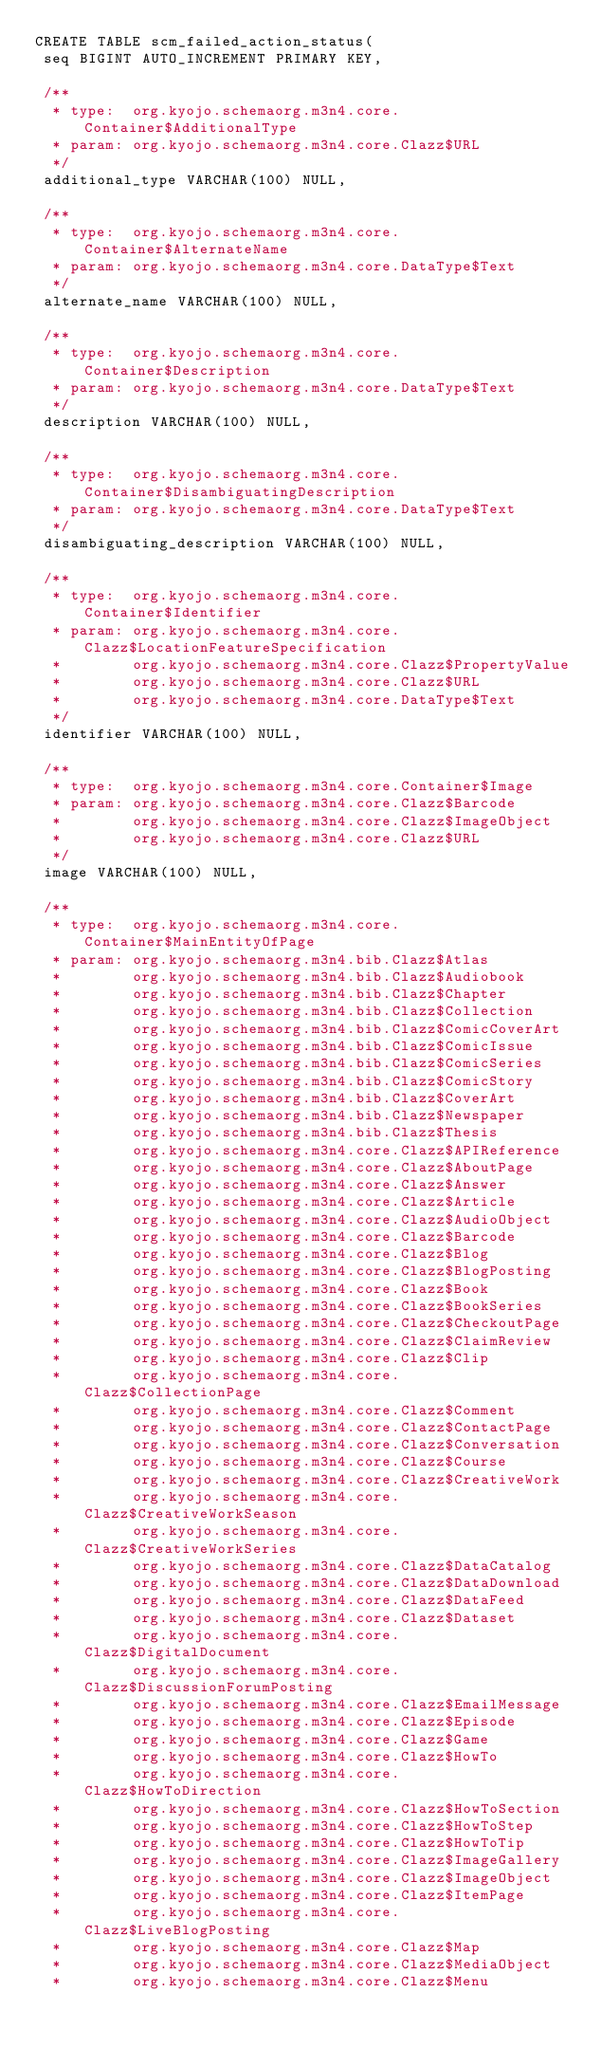<code> <loc_0><loc_0><loc_500><loc_500><_SQL_>CREATE TABLE scm_failed_action_status(
 seq BIGINT AUTO_INCREMENT PRIMARY KEY,

 /**
  * type:  org.kyojo.schemaorg.m3n4.core.Container$AdditionalType
  * param: org.kyojo.schemaorg.m3n4.core.Clazz$URL
  */
 additional_type VARCHAR(100) NULL,

 /**
  * type:  org.kyojo.schemaorg.m3n4.core.Container$AlternateName
  * param: org.kyojo.schemaorg.m3n4.core.DataType$Text
  */
 alternate_name VARCHAR(100) NULL,

 /**
  * type:  org.kyojo.schemaorg.m3n4.core.Container$Description
  * param: org.kyojo.schemaorg.m3n4.core.DataType$Text
  */
 description VARCHAR(100) NULL,

 /**
  * type:  org.kyojo.schemaorg.m3n4.core.Container$DisambiguatingDescription
  * param: org.kyojo.schemaorg.m3n4.core.DataType$Text
  */
 disambiguating_description VARCHAR(100) NULL,

 /**
  * type:  org.kyojo.schemaorg.m3n4.core.Container$Identifier
  * param: org.kyojo.schemaorg.m3n4.core.Clazz$LocationFeatureSpecification
  *        org.kyojo.schemaorg.m3n4.core.Clazz$PropertyValue
  *        org.kyojo.schemaorg.m3n4.core.Clazz$URL
  *        org.kyojo.schemaorg.m3n4.core.DataType$Text
  */
 identifier VARCHAR(100) NULL,

 /**
  * type:  org.kyojo.schemaorg.m3n4.core.Container$Image
  * param: org.kyojo.schemaorg.m3n4.core.Clazz$Barcode
  *        org.kyojo.schemaorg.m3n4.core.Clazz$ImageObject
  *        org.kyojo.schemaorg.m3n4.core.Clazz$URL
  */
 image VARCHAR(100) NULL,

 /**
  * type:  org.kyojo.schemaorg.m3n4.core.Container$MainEntityOfPage
  * param: org.kyojo.schemaorg.m3n4.bib.Clazz$Atlas
  *        org.kyojo.schemaorg.m3n4.bib.Clazz$Audiobook
  *        org.kyojo.schemaorg.m3n4.bib.Clazz$Chapter
  *        org.kyojo.schemaorg.m3n4.bib.Clazz$Collection
  *        org.kyojo.schemaorg.m3n4.bib.Clazz$ComicCoverArt
  *        org.kyojo.schemaorg.m3n4.bib.Clazz$ComicIssue
  *        org.kyojo.schemaorg.m3n4.bib.Clazz$ComicSeries
  *        org.kyojo.schemaorg.m3n4.bib.Clazz$ComicStory
  *        org.kyojo.schemaorg.m3n4.bib.Clazz$CoverArt
  *        org.kyojo.schemaorg.m3n4.bib.Clazz$Newspaper
  *        org.kyojo.schemaorg.m3n4.bib.Clazz$Thesis
  *        org.kyojo.schemaorg.m3n4.core.Clazz$APIReference
  *        org.kyojo.schemaorg.m3n4.core.Clazz$AboutPage
  *        org.kyojo.schemaorg.m3n4.core.Clazz$Answer
  *        org.kyojo.schemaorg.m3n4.core.Clazz$Article
  *        org.kyojo.schemaorg.m3n4.core.Clazz$AudioObject
  *        org.kyojo.schemaorg.m3n4.core.Clazz$Barcode
  *        org.kyojo.schemaorg.m3n4.core.Clazz$Blog
  *        org.kyojo.schemaorg.m3n4.core.Clazz$BlogPosting
  *        org.kyojo.schemaorg.m3n4.core.Clazz$Book
  *        org.kyojo.schemaorg.m3n4.core.Clazz$BookSeries
  *        org.kyojo.schemaorg.m3n4.core.Clazz$CheckoutPage
  *        org.kyojo.schemaorg.m3n4.core.Clazz$ClaimReview
  *        org.kyojo.schemaorg.m3n4.core.Clazz$Clip
  *        org.kyojo.schemaorg.m3n4.core.Clazz$CollectionPage
  *        org.kyojo.schemaorg.m3n4.core.Clazz$Comment
  *        org.kyojo.schemaorg.m3n4.core.Clazz$ContactPage
  *        org.kyojo.schemaorg.m3n4.core.Clazz$Conversation
  *        org.kyojo.schemaorg.m3n4.core.Clazz$Course
  *        org.kyojo.schemaorg.m3n4.core.Clazz$CreativeWork
  *        org.kyojo.schemaorg.m3n4.core.Clazz$CreativeWorkSeason
  *        org.kyojo.schemaorg.m3n4.core.Clazz$CreativeWorkSeries
  *        org.kyojo.schemaorg.m3n4.core.Clazz$DataCatalog
  *        org.kyojo.schemaorg.m3n4.core.Clazz$DataDownload
  *        org.kyojo.schemaorg.m3n4.core.Clazz$DataFeed
  *        org.kyojo.schemaorg.m3n4.core.Clazz$Dataset
  *        org.kyojo.schemaorg.m3n4.core.Clazz$DigitalDocument
  *        org.kyojo.schemaorg.m3n4.core.Clazz$DiscussionForumPosting
  *        org.kyojo.schemaorg.m3n4.core.Clazz$EmailMessage
  *        org.kyojo.schemaorg.m3n4.core.Clazz$Episode
  *        org.kyojo.schemaorg.m3n4.core.Clazz$Game
  *        org.kyojo.schemaorg.m3n4.core.Clazz$HowTo
  *        org.kyojo.schemaorg.m3n4.core.Clazz$HowToDirection
  *        org.kyojo.schemaorg.m3n4.core.Clazz$HowToSection
  *        org.kyojo.schemaorg.m3n4.core.Clazz$HowToStep
  *        org.kyojo.schemaorg.m3n4.core.Clazz$HowToTip
  *        org.kyojo.schemaorg.m3n4.core.Clazz$ImageGallery
  *        org.kyojo.schemaorg.m3n4.core.Clazz$ImageObject
  *        org.kyojo.schemaorg.m3n4.core.Clazz$ItemPage
  *        org.kyojo.schemaorg.m3n4.core.Clazz$LiveBlogPosting
  *        org.kyojo.schemaorg.m3n4.core.Clazz$Map
  *        org.kyojo.schemaorg.m3n4.core.Clazz$MediaObject
  *        org.kyojo.schemaorg.m3n4.core.Clazz$Menu</code> 